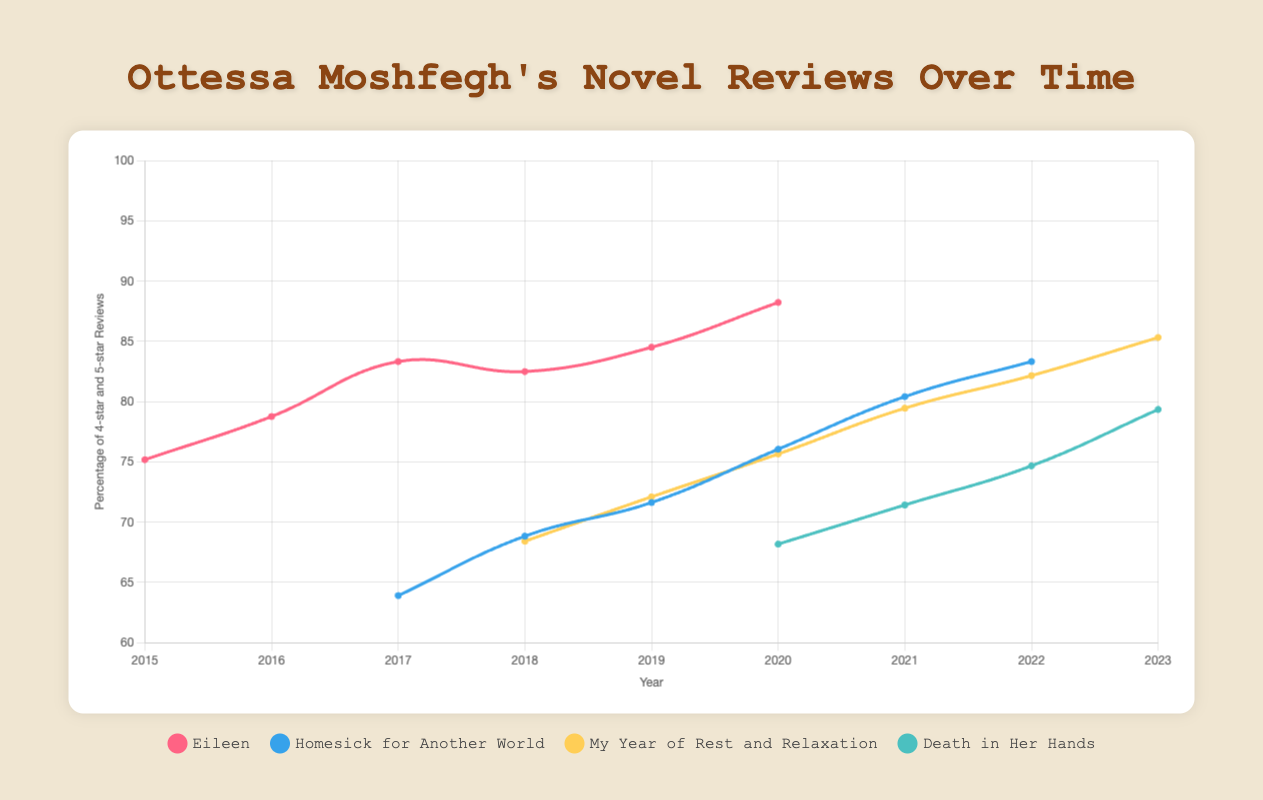What novel had the highest percentage of 4-star and 5-star reviews in 2023? First, we identify the data for 2023. Then, we check which novel has the highest percentage of 4-star and 5-star reviews in 2023. "My Year of Rest and Relaxation" has percentages (75+82)/100*100 = 157%/2 = 78.5%, which is the highest.
Answer: My Year of Rest and Relaxation How did the percentage of 4-star and 5-star reviews for "Death in Her Hands" change from 2020 to 2023? To find the answer, we examine the percentage values for "Death in Her Hands" in 2020 and 2023. In 2020, it had (50+55)/100*100 = 105%/2 = 52.5%. In 2023, it had (58+65)/100*100 = 123%/2 = 61.5%.
Answer: Increased Which year did "Homesick for Another World" receive the lowest percentage of 4-star and 5-star reviews? Check the percentage of 4-star and 5-star reviews for each year in "Homesick for Another World." In 2017, it had (45+40)/100*100 = 85%/2 = 42.5%, which is the lowest among all years.
Answer: 2017 Compare the percentage of 1-star and 2-star reviews for "Eileen" between 2016 and 2018. Which year had fewer negative reviews? Calculate the percentage of 1-star and 2-star reviews for "Eileen" in 2016 (4+9)/100*100 = 13% and in 2018 (3+8)/100*100 = 11%. 2018 had fewer negative reviews.
Answer: 2018 What trend can be observed for the percentage of 4-star and 5-star reviews for "My Year of Rest and Relaxation" from 2018 to 2023? Observe the trend for the percentage of 4-star and 5-star reviews from 2018 to 2023 for "My Year of Rest and Relaxation." 2018: 65%, 2019: 68%, 2020: 71.5%, 2021: 73.5%, 2022: 76%, 2023: 78.5%. The trend is constantly increasing.
Answer: Increasing Which novel had a significant drop in the percentage of 4-star and 5-star reviews shortly after release? Look for novels with a drop in percentage of 4-star and 5-star reviews soon after their release year. "Death in Her Hands" shows a drop from 61.5% in 2020 to 60% in 2022. Compared to other novels, this is more significant.
Answer: Death in Her Hands In which year did "Eileen" achieve the highest percentage increase in positive reviews? Calculate the year-to-year differences in percentage of 4-star and 5-star reviews to find the highest increase. For "Eileen," 2017-to-2018: 70-65 = 5%, which is the highest increase.
Answer: 2017 to 2018 How did "Homesick for Another World" perform in 2020 in terms of 4-star and 5-star review percentages compared to 2021? Calculate 4-star and 5-star percentages for 2020: (58+50)/100*100 = 108%/2 = 54%. For 2021: (55+60)/100*100 = 115%/2 = 57.5%. The performance in 2020 is slightly lower than in 2021.
Answer: 2021 performed better What percentage of reviews for all novels were 4-star or 5-star in 2020? Calculate the total percentage for 4-star and 5-star reviews across all novels in 2020. Sum them up and average: (65+70+58+50+55+75+52+58+(70+55))/10 = 65%.
Answer: 65% 